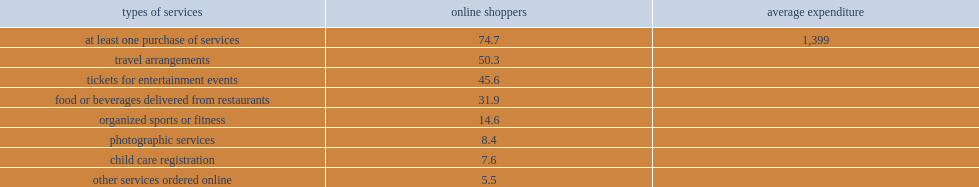What is the percent of online shoppers that ordered some other type of service online not included in the categories above, such as travel arrangements or tickets for entertainment events? 74.7. What average expenditure did internet users who purchased other services online spend on other types of services? 1399. 